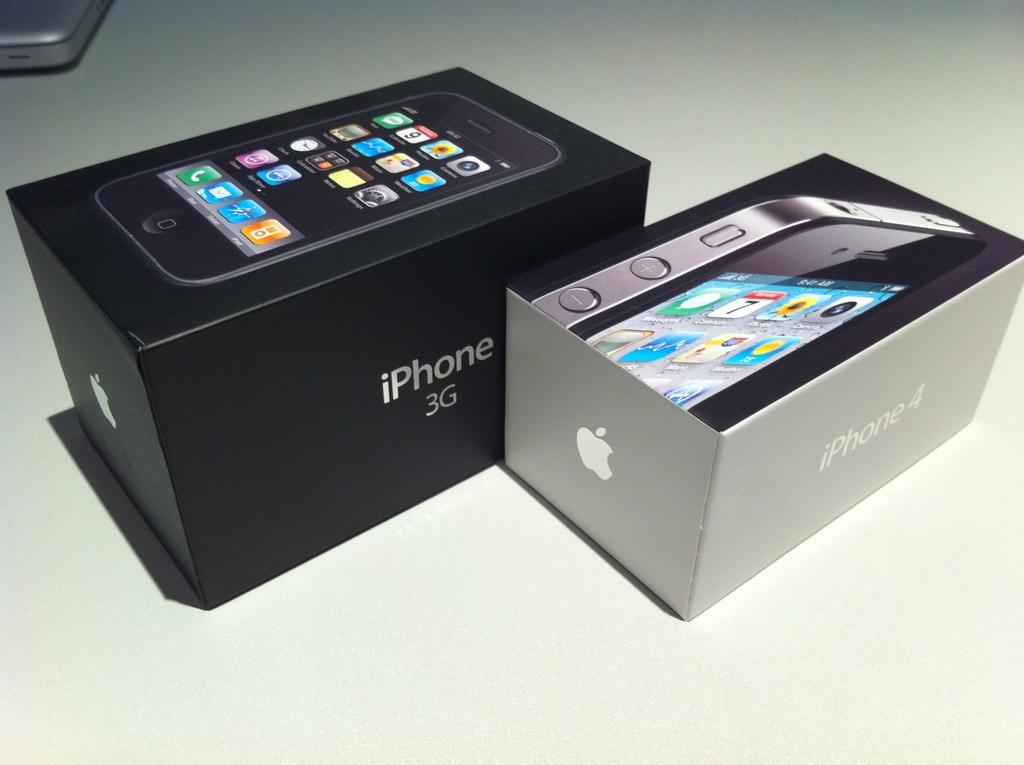<image>
Present a compact description of the photo's key features. A few boxes are on a surface for an Apple iPhone 3G and iPhone 4. 